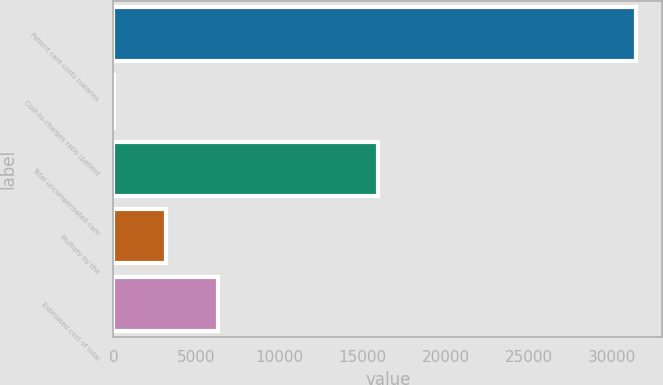Convert chart. <chart><loc_0><loc_0><loc_500><loc_500><bar_chart><fcel>Patient care costs (salaries<fcel>Cost-to-charges ratio (patient<fcel>Total uncompensated care<fcel>Multiply by the<fcel>Estimated cost of total<nl><fcel>31478<fcel>15.5<fcel>15943<fcel>3161.75<fcel>6308<nl></chart> 